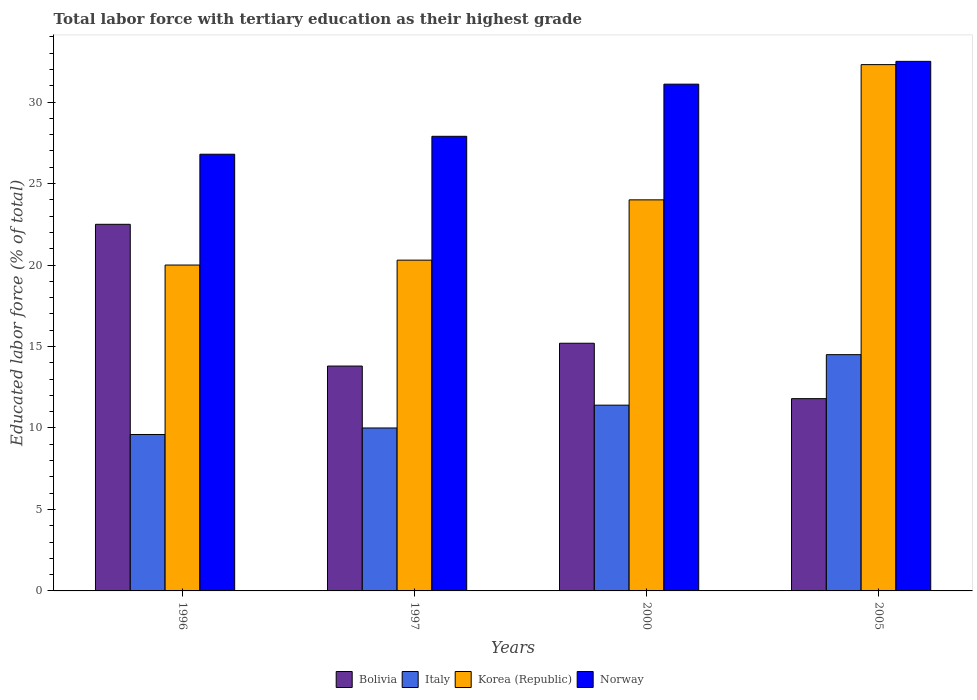How many different coloured bars are there?
Give a very brief answer. 4. How many groups of bars are there?
Ensure brevity in your answer.  4. Are the number of bars per tick equal to the number of legend labels?
Your answer should be compact. Yes. How many bars are there on the 1st tick from the left?
Make the answer very short. 4. What is the percentage of male labor force with tertiary education in Korea (Republic) in 1997?
Ensure brevity in your answer.  20.3. Across all years, what is the maximum percentage of male labor force with tertiary education in Italy?
Your response must be concise. 14.5. Across all years, what is the minimum percentage of male labor force with tertiary education in Italy?
Give a very brief answer. 9.6. What is the total percentage of male labor force with tertiary education in Italy in the graph?
Make the answer very short. 45.5. What is the difference between the percentage of male labor force with tertiary education in Bolivia in 1996 and that in 2000?
Offer a very short reply. 7.3. What is the difference between the percentage of male labor force with tertiary education in Italy in 2005 and the percentage of male labor force with tertiary education in Norway in 1996?
Offer a very short reply. -12.3. What is the average percentage of male labor force with tertiary education in Italy per year?
Keep it short and to the point. 11.38. In the year 1997, what is the difference between the percentage of male labor force with tertiary education in Italy and percentage of male labor force with tertiary education in Korea (Republic)?
Your answer should be very brief. -10.3. In how many years, is the percentage of male labor force with tertiary education in Bolivia greater than 3 %?
Keep it short and to the point. 4. What is the ratio of the percentage of male labor force with tertiary education in Italy in 1997 to that in 2005?
Provide a short and direct response. 0.69. What is the difference between the highest and the second highest percentage of male labor force with tertiary education in Bolivia?
Make the answer very short. 7.3. What is the difference between the highest and the lowest percentage of male labor force with tertiary education in Norway?
Give a very brief answer. 5.7. Is the sum of the percentage of male labor force with tertiary education in Korea (Republic) in 2000 and 2005 greater than the maximum percentage of male labor force with tertiary education in Norway across all years?
Offer a terse response. Yes. Is it the case that in every year, the sum of the percentage of male labor force with tertiary education in Italy and percentage of male labor force with tertiary education in Korea (Republic) is greater than the sum of percentage of male labor force with tertiary education in Bolivia and percentage of male labor force with tertiary education in Norway?
Your answer should be compact. No. Are all the bars in the graph horizontal?
Keep it short and to the point. No. How many years are there in the graph?
Your answer should be very brief. 4. Does the graph contain grids?
Your response must be concise. No. How many legend labels are there?
Your answer should be very brief. 4. What is the title of the graph?
Provide a short and direct response. Total labor force with tertiary education as their highest grade. Does "Caribbean small states" appear as one of the legend labels in the graph?
Give a very brief answer. No. What is the label or title of the X-axis?
Provide a succinct answer. Years. What is the label or title of the Y-axis?
Your answer should be very brief. Educated labor force (% of total). What is the Educated labor force (% of total) in Italy in 1996?
Offer a terse response. 9.6. What is the Educated labor force (% of total) of Norway in 1996?
Provide a short and direct response. 26.8. What is the Educated labor force (% of total) of Bolivia in 1997?
Your answer should be compact. 13.8. What is the Educated labor force (% of total) in Italy in 1997?
Provide a short and direct response. 10. What is the Educated labor force (% of total) of Korea (Republic) in 1997?
Give a very brief answer. 20.3. What is the Educated labor force (% of total) in Norway in 1997?
Keep it short and to the point. 27.9. What is the Educated labor force (% of total) in Bolivia in 2000?
Keep it short and to the point. 15.2. What is the Educated labor force (% of total) in Italy in 2000?
Give a very brief answer. 11.4. What is the Educated labor force (% of total) of Norway in 2000?
Your answer should be compact. 31.1. What is the Educated labor force (% of total) of Bolivia in 2005?
Offer a terse response. 11.8. What is the Educated labor force (% of total) of Korea (Republic) in 2005?
Offer a terse response. 32.3. What is the Educated labor force (% of total) of Norway in 2005?
Your answer should be compact. 32.5. Across all years, what is the maximum Educated labor force (% of total) of Italy?
Make the answer very short. 14.5. Across all years, what is the maximum Educated labor force (% of total) of Korea (Republic)?
Offer a terse response. 32.3. Across all years, what is the maximum Educated labor force (% of total) of Norway?
Keep it short and to the point. 32.5. Across all years, what is the minimum Educated labor force (% of total) in Bolivia?
Give a very brief answer. 11.8. Across all years, what is the minimum Educated labor force (% of total) in Italy?
Provide a short and direct response. 9.6. Across all years, what is the minimum Educated labor force (% of total) in Norway?
Your answer should be compact. 26.8. What is the total Educated labor force (% of total) in Bolivia in the graph?
Your answer should be very brief. 63.3. What is the total Educated labor force (% of total) in Italy in the graph?
Keep it short and to the point. 45.5. What is the total Educated labor force (% of total) in Korea (Republic) in the graph?
Give a very brief answer. 96.6. What is the total Educated labor force (% of total) of Norway in the graph?
Your answer should be compact. 118.3. What is the difference between the Educated labor force (% of total) in Korea (Republic) in 1996 and that in 1997?
Give a very brief answer. -0.3. What is the difference between the Educated labor force (% of total) in Bolivia in 1996 and that in 2000?
Make the answer very short. 7.3. What is the difference between the Educated labor force (% of total) in Norway in 1996 and that in 2000?
Give a very brief answer. -4.3. What is the difference between the Educated labor force (% of total) in Italy in 1996 and that in 2005?
Make the answer very short. -4.9. What is the difference between the Educated labor force (% of total) of Norway in 1996 and that in 2005?
Your response must be concise. -5.7. What is the difference between the Educated labor force (% of total) in Korea (Republic) in 1997 and that in 2000?
Give a very brief answer. -3.7. What is the difference between the Educated labor force (% of total) of Bolivia in 1997 and that in 2005?
Keep it short and to the point. 2. What is the difference between the Educated labor force (% of total) in Norway in 1997 and that in 2005?
Your response must be concise. -4.6. What is the difference between the Educated labor force (% of total) of Italy in 2000 and that in 2005?
Offer a terse response. -3.1. What is the difference between the Educated labor force (% of total) of Korea (Republic) in 2000 and that in 2005?
Offer a terse response. -8.3. What is the difference between the Educated labor force (% of total) in Bolivia in 1996 and the Educated labor force (% of total) in Korea (Republic) in 1997?
Provide a short and direct response. 2.2. What is the difference between the Educated labor force (% of total) in Bolivia in 1996 and the Educated labor force (% of total) in Norway in 1997?
Make the answer very short. -5.4. What is the difference between the Educated labor force (% of total) in Italy in 1996 and the Educated labor force (% of total) in Korea (Republic) in 1997?
Offer a very short reply. -10.7. What is the difference between the Educated labor force (% of total) of Italy in 1996 and the Educated labor force (% of total) of Norway in 1997?
Provide a short and direct response. -18.3. What is the difference between the Educated labor force (% of total) in Korea (Republic) in 1996 and the Educated labor force (% of total) in Norway in 1997?
Your answer should be very brief. -7.9. What is the difference between the Educated labor force (% of total) in Italy in 1996 and the Educated labor force (% of total) in Korea (Republic) in 2000?
Your answer should be very brief. -14.4. What is the difference between the Educated labor force (% of total) in Italy in 1996 and the Educated labor force (% of total) in Norway in 2000?
Your answer should be compact. -21.5. What is the difference between the Educated labor force (% of total) in Bolivia in 1996 and the Educated labor force (% of total) in Italy in 2005?
Offer a terse response. 8. What is the difference between the Educated labor force (% of total) in Bolivia in 1996 and the Educated labor force (% of total) in Korea (Republic) in 2005?
Make the answer very short. -9.8. What is the difference between the Educated labor force (% of total) of Italy in 1996 and the Educated labor force (% of total) of Korea (Republic) in 2005?
Offer a terse response. -22.7. What is the difference between the Educated labor force (% of total) of Italy in 1996 and the Educated labor force (% of total) of Norway in 2005?
Give a very brief answer. -22.9. What is the difference between the Educated labor force (% of total) of Korea (Republic) in 1996 and the Educated labor force (% of total) of Norway in 2005?
Offer a terse response. -12.5. What is the difference between the Educated labor force (% of total) of Bolivia in 1997 and the Educated labor force (% of total) of Italy in 2000?
Offer a terse response. 2.4. What is the difference between the Educated labor force (% of total) of Bolivia in 1997 and the Educated labor force (% of total) of Norway in 2000?
Make the answer very short. -17.3. What is the difference between the Educated labor force (% of total) in Italy in 1997 and the Educated labor force (% of total) in Korea (Republic) in 2000?
Keep it short and to the point. -14. What is the difference between the Educated labor force (% of total) in Italy in 1997 and the Educated labor force (% of total) in Norway in 2000?
Your answer should be very brief. -21.1. What is the difference between the Educated labor force (% of total) in Korea (Republic) in 1997 and the Educated labor force (% of total) in Norway in 2000?
Ensure brevity in your answer.  -10.8. What is the difference between the Educated labor force (% of total) in Bolivia in 1997 and the Educated labor force (% of total) in Italy in 2005?
Your answer should be very brief. -0.7. What is the difference between the Educated labor force (% of total) of Bolivia in 1997 and the Educated labor force (% of total) of Korea (Republic) in 2005?
Your answer should be very brief. -18.5. What is the difference between the Educated labor force (% of total) in Bolivia in 1997 and the Educated labor force (% of total) in Norway in 2005?
Ensure brevity in your answer.  -18.7. What is the difference between the Educated labor force (% of total) of Italy in 1997 and the Educated labor force (% of total) of Korea (Republic) in 2005?
Ensure brevity in your answer.  -22.3. What is the difference between the Educated labor force (% of total) in Italy in 1997 and the Educated labor force (% of total) in Norway in 2005?
Keep it short and to the point. -22.5. What is the difference between the Educated labor force (% of total) of Korea (Republic) in 1997 and the Educated labor force (% of total) of Norway in 2005?
Give a very brief answer. -12.2. What is the difference between the Educated labor force (% of total) of Bolivia in 2000 and the Educated labor force (% of total) of Italy in 2005?
Your answer should be very brief. 0.7. What is the difference between the Educated labor force (% of total) in Bolivia in 2000 and the Educated labor force (% of total) in Korea (Republic) in 2005?
Provide a short and direct response. -17.1. What is the difference between the Educated labor force (% of total) in Bolivia in 2000 and the Educated labor force (% of total) in Norway in 2005?
Your answer should be very brief. -17.3. What is the difference between the Educated labor force (% of total) of Italy in 2000 and the Educated labor force (% of total) of Korea (Republic) in 2005?
Provide a succinct answer. -20.9. What is the difference between the Educated labor force (% of total) of Italy in 2000 and the Educated labor force (% of total) of Norway in 2005?
Provide a succinct answer. -21.1. What is the difference between the Educated labor force (% of total) of Korea (Republic) in 2000 and the Educated labor force (% of total) of Norway in 2005?
Offer a very short reply. -8.5. What is the average Educated labor force (% of total) of Bolivia per year?
Keep it short and to the point. 15.82. What is the average Educated labor force (% of total) in Italy per year?
Give a very brief answer. 11.38. What is the average Educated labor force (% of total) in Korea (Republic) per year?
Ensure brevity in your answer.  24.15. What is the average Educated labor force (% of total) of Norway per year?
Ensure brevity in your answer.  29.57. In the year 1996, what is the difference between the Educated labor force (% of total) in Italy and Educated labor force (% of total) in Norway?
Provide a succinct answer. -17.2. In the year 1996, what is the difference between the Educated labor force (% of total) in Korea (Republic) and Educated labor force (% of total) in Norway?
Provide a short and direct response. -6.8. In the year 1997, what is the difference between the Educated labor force (% of total) in Bolivia and Educated labor force (% of total) in Norway?
Your response must be concise. -14.1. In the year 1997, what is the difference between the Educated labor force (% of total) of Italy and Educated labor force (% of total) of Korea (Republic)?
Your answer should be compact. -10.3. In the year 1997, what is the difference between the Educated labor force (% of total) of Italy and Educated labor force (% of total) of Norway?
Provide a short and direct response. -17.9. In the year 2000, what is the difference between the Educated labor force (% of total) of Bolivia and Educated labor force (% of total) of Italy?
Provide a short and direct response. 3.8. In the year 2000, what is the difference between the Educated labor force (% of total) in Bolivia and Educated labor force (% of total) in Norway?
Offer a very short reply. -15.9. In the year 2000, what is the difference between the Educated labor force (% of total) of Italy and Educated labor force (% of total) of Norway?
Your answer should be compact. -19.7. In the year 2000, what is the difference between the Educated labor force (% of total) in Korea (Republic) and Educated labor force (% of total) in Norway?
Your answer should be very brief. -7.1. In the year 2005, what is the difference between the Educated labor force (% of total) in Bolivia and Educated labor force (% of total) in Italy?
Provide a short and direct response. -2.7. In the year 2005, what is the difference between the Educated labor force (% of total) of Bolivia and Educated labor force (% of total) of Korea (Republic)?
Your answer should be very brief. -20.5. In the year 2005, what is the difference between the Educated labor force (% of total) of Bolivia and Educated labor force (% of total) of Norway?
Offer a very short reply. -20.7. In the year 2005, what is the difference between the Educated labor force (% of total) in Italy and Educated labor force (% of total) in Korea (Republic)?
Provide a succinct answer. -17.8. What is the ratio of the Educated labor force (% of total) in Bolivia in 1996 to that in 1997?
Provide a succinct answer. 1.63. What is the ratio of the Educated labor force (% of total) in Korea (Republic) in 1996 to that in 1997?
Give a very brief answer. 0.99. What is the ratio of the Educated labor force (% of total) of Norway in 1996 to that in 1997?
Offer a very short reply. 0.96. What is the ratio of the Educated labor force (% of total) of Bolivia in 1996 to that in 2000?
Keep it short and to the point. 1.48. What is the ratio of the Educated labor force (% of total) in Italy in 1996 to that in 2000?
Offer a terse response. 0.84. What is the ratio of the Educated labor force (% of total) in Norway in 1996 to that in 2000?
Keep it short and to the point. 0.86. What is the ratio of the Educated labor force (% of total) of Bolivia in 1996 to that in 2005?
Offer a very short reply. 1.91. What is the ratio of the Educated labor force (% of total) in Italy in 1996 to that in 2005?
Offer a terse response. 0.66. What is the ratio of the Educated labor force (% of total) in Korea (Republic) in 1996 to that in 2005?
Your answer should be compact. 0.62. What is the ratio of the Educated labor force (% of total) of Norway in 1996 to that in 2005?
Offer a very short reply. 0.82. What is the ratio of the Educated labor force (% of total) in Bolivia in 1997 to that in 2000?
Make the answer very short. 0.91. What is the ratio of the Educated labor force (% of total) in Italy in 1997 to that in 2000?
Ensure brevity in your answer.  0.88. What is the ratio of the Educated labor force (% of total) in Korea (Republic) in 1997 to that in 2000?
Make the answer very short. 0.85. What is the ratio of the Educated labor force (% of total) of Norway in 1997 to that in 2000?
Provide a short and direct response. 0.9. What is the ratio of the Educated labor force (% of total) in Bolivia in 1997 to that in 2005?
Offer a very short reply. 1.17. What is the ratio of the Educated labor force (% of total) in Italy in 1997 to that in 2005?
Give a very brief answer. 0.69. What is the ratio of the Educated labor force (% of total) in Korea (Republic) in 1997 to that in 2005?
Provide a succinct answer. 0.63. What is the ratio of the Educated labor force (% of total) in Norway in 1997 to that in 2005?
Give a very brief answer. 0.86. What is the ratio of the Educated labor force (% of total) in Bolivia in 2000 to that in 2005?
Your response must be concise. 1.29. What is the ratio of the Educated labor force (% of total) of Italy in 2000 to that in 2005?
Give a very brief answer. 0.79. What is the ratio of the Educated labor force (% of total) of Korea (Republic) in 2000 to that in 2005?
Your response must be concise. 0.74. What is the ratio of the Educated labor force (% of total) in Norway in 2000 to that in 2005?
Give a very brief answer. 0.96. What is the difference between the highest and the second highest Educated labor force (% of total) of Italy?
Ensure brevity in your answer.  3.1. What is the difference between the highest and the lowest Educated labor force (% of total) in Bolivia?
Offer a terse response. 10.7. What is the difference between the highest and the lowest Educated labor force (% of total) in Korea (Republic)?
Provide a short and direct response. 12.3. 